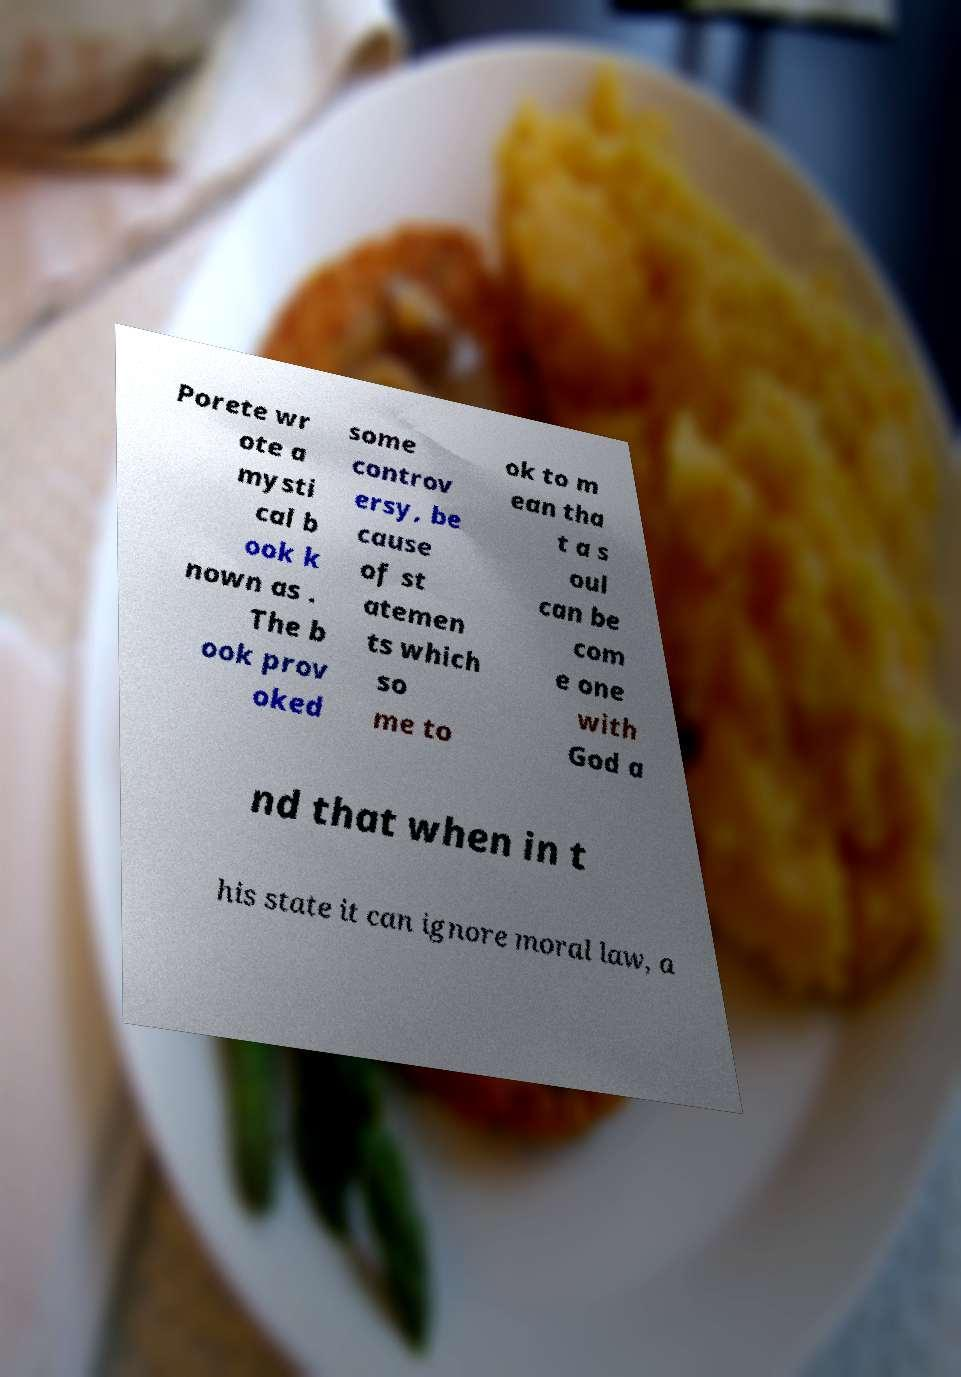Could you assist in decoding the text presented in this image and type it out clearly? Porete wr ote a mysti cal b ook k nown as . The b ook prov oked some controv ersy, be cause of st atemen ts which so me to ok to m ean tha t a s oul can be com e one with God a nd that when in t his state it can ignore moral law, a 